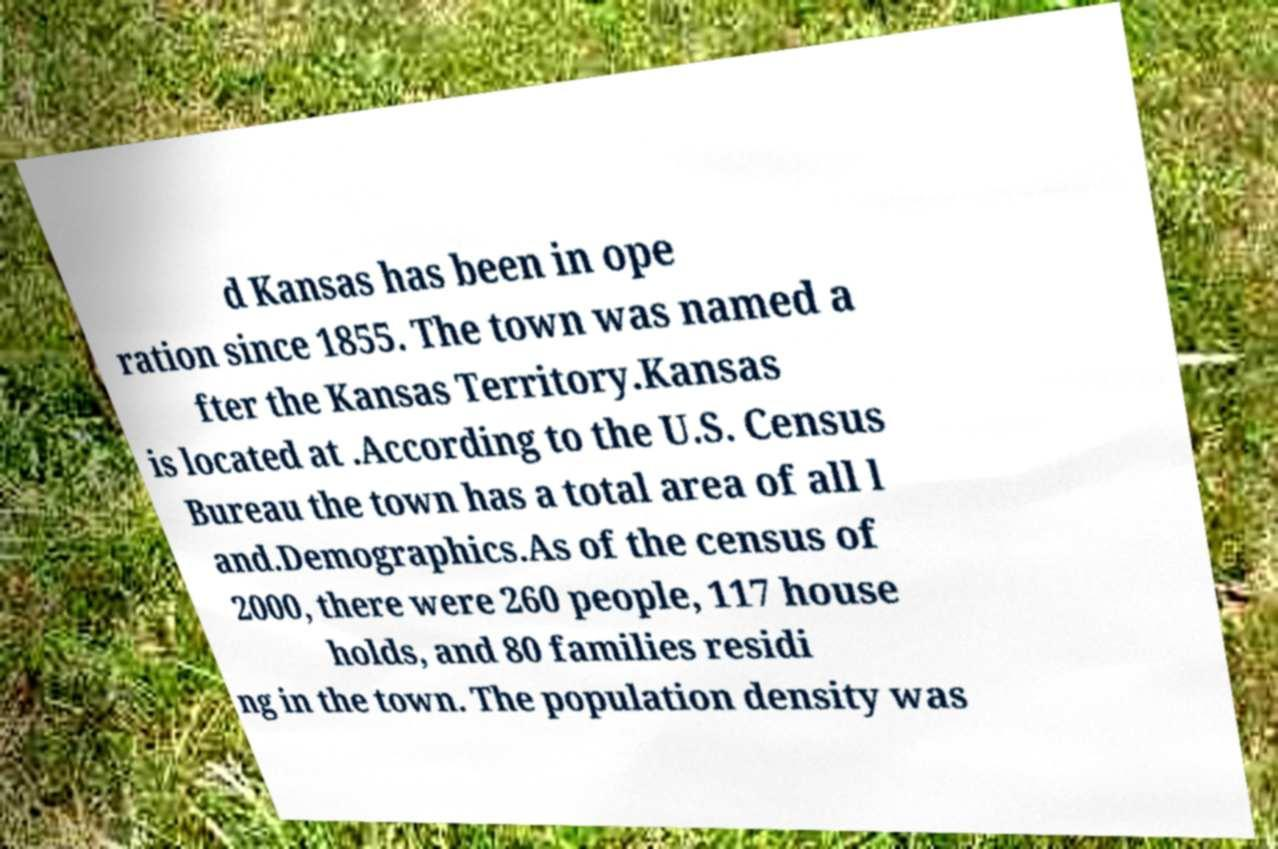Please read and relay the text visible in this image. What does it say? d Kansas has been in ope ration since 1855. The town was named a fter the Kansas Territory.Kansas is located at .According to the U.S. Census Bureau the town has a total area of all l and.Demographics.As of the census of 2000, there were 260 people, 117 house holds, and 80 families residi ng in the town. The population density was 